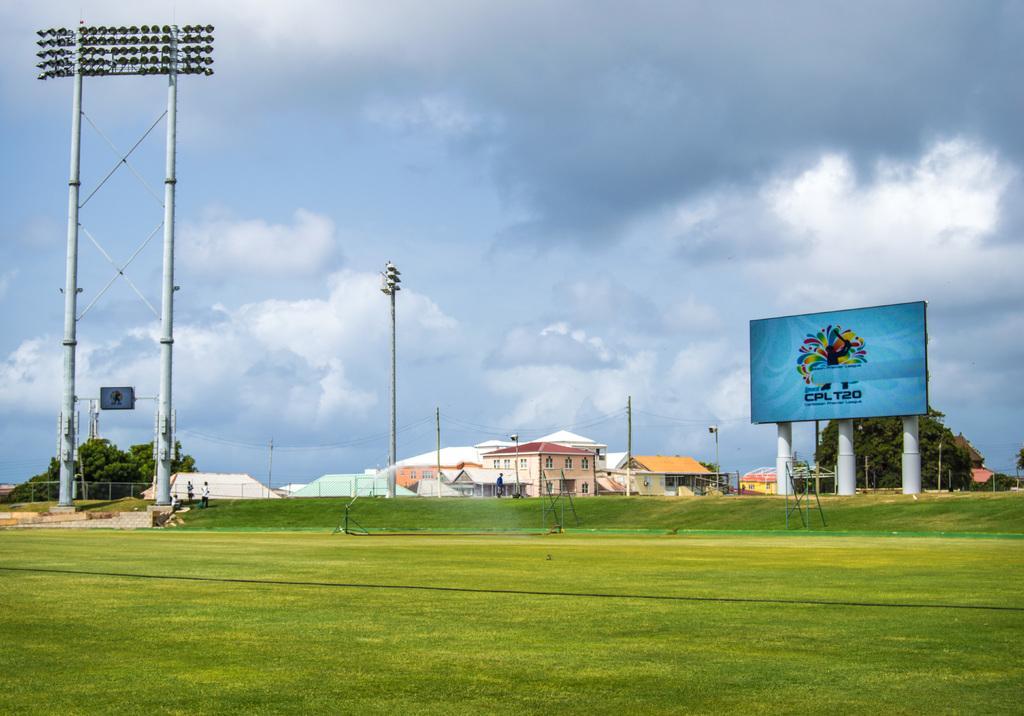In one or two sentences, can you explain what this image depicts? In the foreground of this image, there is grass on the ground. In the background, there is a ladder, poles, cables, stadium light, a screen, few trees, persons standing, buildings, sky and the cloud. 